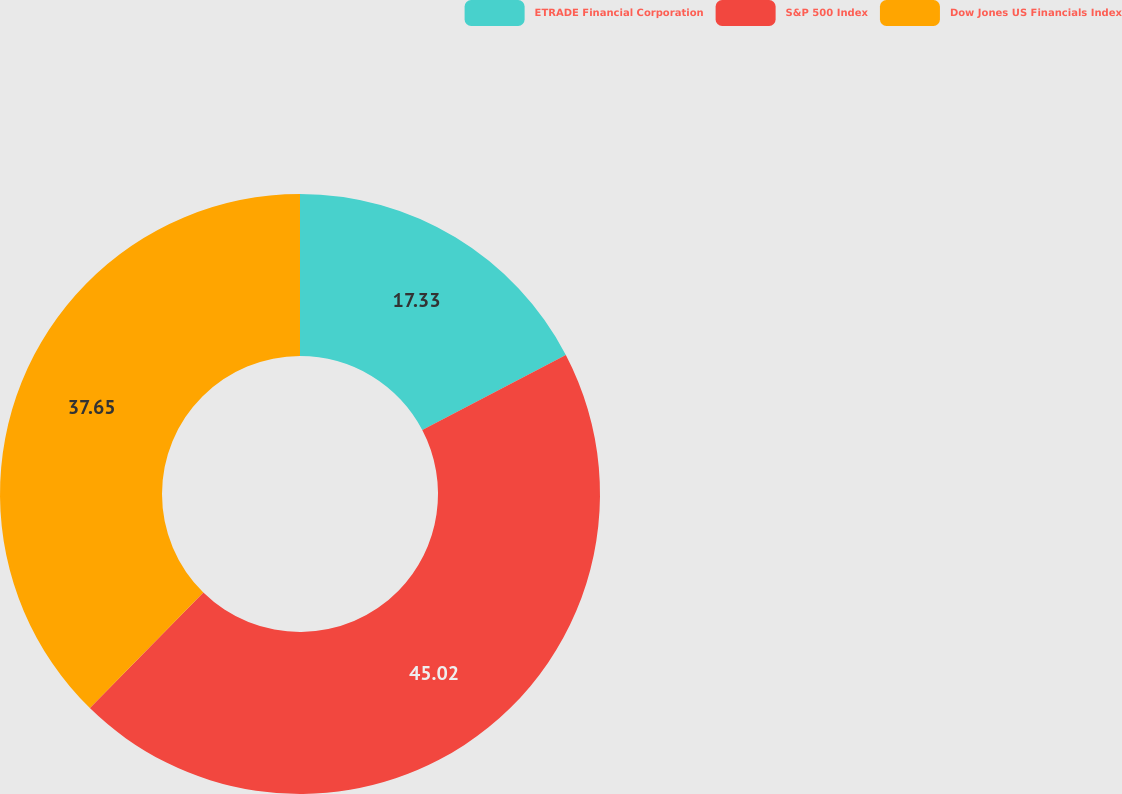<chart> <loc_0><loc_0><loc_500><loc_500><pie_chart><fcel>ETRADE Financial Corporation<fcel>S&P 500 Index<fcel>Dow Jones US Financials Index<nl><fcel>17.33%<fcel>45.02%<fcel>37.65%<nl></chart> 